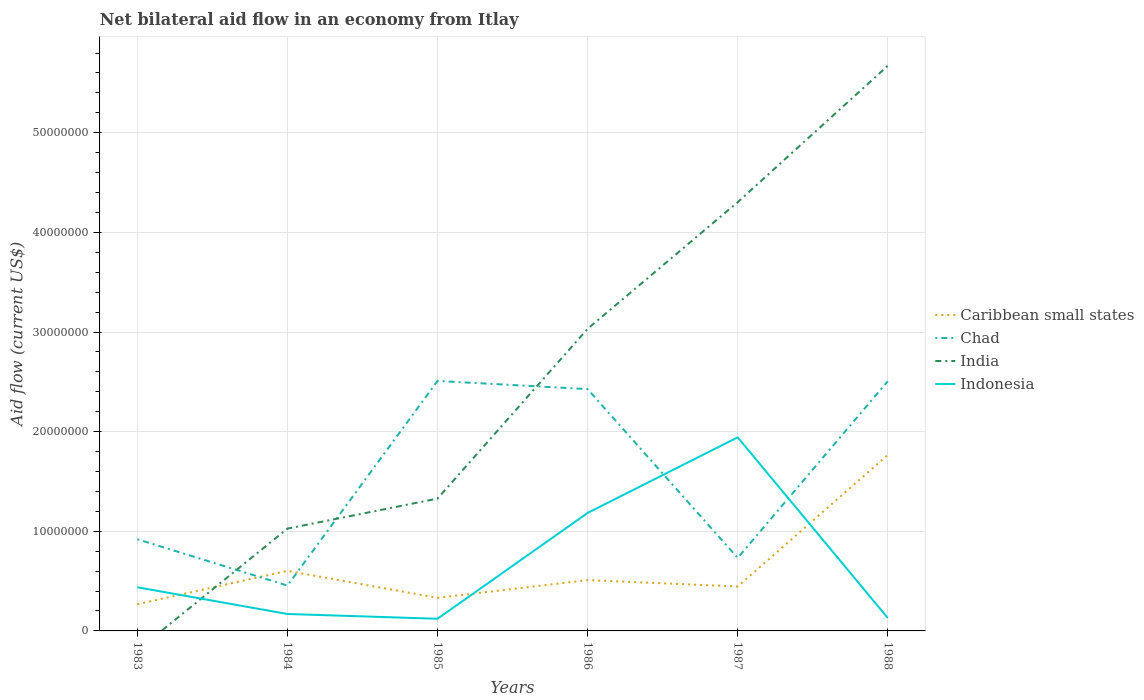Across all years, what is the maximum net bilateral aid flow in India?
Your response must be concise. 0. What is the total net bilateral aid flow in Indonesia in the graph?
Ensure brevity in your answer.  -7.59e+06. What is the difference between the highest and the second highest net bilateral aid flow in Caribbean small states?
Your answer should be compact. 1.50e+07. Is the net bilateral aid flow in Indonesia strictly greater than the net bilateral aid flow in India over the years?
Offer a very short reply. No. Are the values on the major ticks of Y-axis written in scientific E-notation?
Give a very brief answer. No. Does the graph contain any zero values?
Your response must be concise. Yes. Does the graph contain grids?
Your answer should be compact. Yes. Where does the legend appear in the graph?
Your answer should be compact. Center right. What is the title of the graph?
Ensure brevity in your answer.  Net bilateral aid flow in an economy from Itlay. Does "Cameroon" appear as one of the legend labels in the graph?
Provide a short and direct response. No. What is the label or title of the Y-axis?
Provide a succinct answer. Aid flow (current US$). What is the Aid flow (current US$) in Caribbean small states in 1983?
Provide a short and direct response. 2.68e+06. What is the Aid flow (current US$) of Chad in 1983?
Provide a succinct answer. 9.20e+06. What is the Aid flow (current US$) of Indonesia in 1983?
Provide a succinct answer. 4.38e+06. What is the Aid flow (current US$) of Caribbean small states in 1984?
Ensure brevity in your answer.  6.03e+06. What is the Aid flow (current US$) of Chad in 1984?
Offer a terse response. 4.55e+06. What is the Aid flow (current US$) in India in 1984?
Make the answer very short. 1.03e+07. What is the Aid flow (current US$) of Indonesia in 1984?
Your response must be concise. 1.70e+06. What is the Aid flow (current US$) in Caribbean small states in 1985?
Make the answer very short. 3.32e+06. What is the Aid flow (current US$) in Chad in 1985?
Provide a short and direct response. 2.51e+07. What is the Aid flow (current US$) of India in 1985?
Your answer should be very brief. 1.33e+07. What is the Aid flow (current US$) in Indonesia in 1985?
Your answer should be very brief. 1.22e+06. What is the Aid flow (current US$) of Caribbean small states in 1986?
Offer a terse response. 5.10e+06. What is the Aid flow (current US$) in Chad in 1986?
Ensure brevity in your answer.  2.43e+07. What is the Aid flow (current US$) in India in 1986?
Give a very brief answer. 3.03e+07. What is the Aid flow (current US$) in Indonesia in 1986?
Make the answer very short. 1.18e+07. What is the Aid flow (current US$) in Caribbean small states in 1987?
Offer a terse response. 4.46e+06. What is the Aid flow (current US$) of Chad in 1987?
Provide a succinct answer. 7.33e+06. What is the Aid flow (current US$) of India in 1987?
Your answer should be very brief. 4.30e+07. What is the Aid flow (current US$) in Indonesia in 1987?
Offer a very short reply. 1.94e+07. What is the Aid flow (current US$) in Caribbean small states in 1988?
Keep it short and to the point. 1.77e+07. What is the Aid flow (current US$) in Chad in 1988?
Offer a very short reply. 2.51e+07. What is the Aid flow (current US$) of India in 1988?
Ensure brevity in your answer.  5.67e+07. What is the Aid flow (current US$) in Indonesia in 1988?
Provide a succinct answer. 1.30e+06. Across all years, what is the maximum Aid flow (current US$) of Caribbean small states?
Provide a succinct answer. 1.77e+07. Across all years, what is the maximum Aid flow (current US$) of Chad?
Keep it short and to the point. 2.51e+07. Across all years, what is the maximum Aid flow (current US$) of India?
Provide a short and direct response. 5.67e+07. Across all years, what is the maximum Aid flow (current US$) of Indonesia?
Provide a short and direct response. 1.94e+07. Across all years, what is the minimum Aid flow (current US$) in Caribbean small states?
Keep it short and to the point. 2.68e+06. Across all years, what is the minimum Aid flow (current US$) of Chad?
Offer a terse response. 4.55e+06. Across all years, what is the minimum Aid flow (current US$) of India?
Ensure brevity in your answer.  0. Across all years, what is the minimum Aid flow (current US$) in Indonesia?
Ensure brevity in your answer.  1.22e+06. What is the total Aid flow (current US$) in Caribbean small states in the graph?
Provide a short and direct response. 3.92e+07. What is the total Aid flow (current US$) of Chad in the graph?
Give a very brief answer. 9.55e+07. What is the total Aid flow (current US$) in India in the graph?
Your response must be concise. 1.54e+08. What is the total Aid flow (current US$) in Indonesia in the graph?
Give a very brief answer. 3.99e+07. What is the difference between the Aid flow (current US$) in Caribbean small states in 1983 and that in 1984?
Give a very brief answer. -3.35e+06. What is the difference between the Aid flow (current US$) of Chad in 1983 and that in 1984?
Your answer should be compact. 4.65e+06. What is the difference between the Aid flow (current US$) in Indonesia in 1983 and that in 1984?
Provide a succinct answer. 2.68e+06. What is the difference between the Aid flow (current US$) of Caribbean small states in 1983 and that in 1985?
Your response must be concise. -6.40e+05. What is the difference between the Aid flow (current US$) in Chad in 1983 and that in 1985?
Make the answer very short. -1.59e+07. What is the difference between the Aid flow (current US$) of Indonesia in 1983 and that in 1985?
Provide a short and direct response. 3.16e+06. What is the difference between the Aid flow (current US$) of Caribbean small states in 1983 and that in 1986?
Provide a short and direct response. -2.42e+06. What is the difference between the Aid flow (current US$) in Chad in 1983 and that in 1986?
Provide a succinct answer. -1.51e+07. What is the difference between the Aid flow (current US$) in Indonesia in 1983 and that in 1986?
Your answer should be very brief. -7.46e+06. What is the difference between the Aid flow (current US$) in Caribbean small states in 1983 and that in 1987?
Your answer should be very brief. -1.78e+06. What is the difference between the Aid flow (current US$) in Chad in 1983 and that in 1987?
Your response must be concise. 1.87e+06. What is the difference between the Aid flow (current US$) in Indonesia in 1983 and that in 1987?
Give a very brief answer. -1.50e+07. What is the difference between the Aid flow (current US$) in Caribbean small states in 1983 and that in 1988?
Keep it short and to the point. -1.50e+07. What is the difference between the Aid flow (current US$) in Chad in 1983 and that in 1988?
Keep it short and to the point. -1.59e+07. What is the difference between the Aid flow (current US$) of Indonesia in 1983 and that in 1988?
Your answer should be very brief. 3.08e+06. What is the difference between the Aid flow (current US$) of Caribbean small states in 1984 and that in 1985?
Ensure brevity in your answer.  2.71e+06. What is the difference between the Aid flow (current US$) of Chad in 1984 and that in 1985?
Offer a terse response. -2.05e+07. What is the difference between the Aid flow (current US$) in India in 1984 and that in 1985?
Provide a succinct answer. -3.01e+06. What is the difference between the Aid flow (current US$) in Caribbean small states in 1984 and that in 1986?
Your answer should be compact. 9.30e+05. What is the difference between the Aid flow (current US$) in Chad in 1984 and that in 1986?
Your response must be concise. -1.97e+07. What is the difference between the Aid flow (current US$) of India in 1984 and that in 1986?
Provide a succinct answer. -2.00e+07. What is the difference between the Aid flow (current US$) of Indonesia in 1984 and that in 1986?
Your response must be concise. -1.01e+07. What is the difference between the Aid flow (current US$) of Caribbean small states in 1984 and that in 1987?
Give a very brief answer. 1.57e+06. What is the difference between the Aid flow (current US$) in Chad in 1984 and that in 1987?
Your response must be concise. -2.78e+06. What is the difference between the Aid flow (current US$) of India in 1984 and that in 1987?
Give a very brief answer. -3.28e+07. What is the difference between the Aid flow (current US$) of Indonesia in 1984 and that in 1987?
Your answer should be very brief. -1.77e+07. What is the difference between the Aid flow (current US$) of Caribbean small states in 1984 and that in 1988?
Provide a succinct answer. -1.16e+07. What is the difference between the Aid flow (current US$) in Chad in 1984 and that in 1988?
Offer a terse response. -2.05e+07. What is the difference between the Aid flow (current US$) in India in 1984 and that in 1988?
Your answer should be very brief. -4.64e+07. What is the difference between the Aid flow (current US$) in Indonesia in 1984 and that in 1988?
Your response must be concise. 4.00e+05. What is the difference between the Aid flow (current US$) of Caribbean small states in 1985 and that in 1986?
Provide a short and direct response. -1.78e+06. What is the difference between the Aid flow (current US$) in Chad in 1985 and that in 1986?
Provide a short and direct response. 8.20e+05. What is the difference between the Aid flow (current US$) in India in 1985 and that in 1986?
Your response must be concise. -1.70e+07. What is the difference between the Aid flow (current US$) of Indonesia in 1985 and that in 1986?
Your answer should be very brief. -1.06e+07. What is the difference between the Aid flow (current US$) in Caribbean small states in 1985 and that in 1987?
Offer a terse response. -1.14e+06. What is the difference between the Aid flow (current US$) of Chad in 1985 and that in 1987?
Offer a terse response. 1.78e+07. What is the difference between the Aid flow (current US$) of India in 1985 and that in 1987?
Keep it short and to the point. -2.98e+07. What is the difference between the Aid flow (current US$) of Indonesia in 1985 and that in 1987?
Ensure brevity in your answer.  -1.82e+07. What is the difference between the Aid flow (current US$) in Caribbean small states in 1985 and that in 1988?
Your answer should be compact. -1.43e+07. What is the difference between the Aid flow (current US$) in India in 1985 and that in 1988?
Your response must be concise. -4.34e+07. What is the difference between the Aid flow (current US$) in Caribbean small states in 1986 and that in 1987?
Ensure brevity in your answer.  6.40e+05. What is the difference between the Aid flow (current US$) in Chad in 1986 and that in 1987?
Your answer should be compact. 1.69e+07. What is the difference between the Aid flow (current US$) in India in 1986 and that in 1987?
Provide a succinct answer. -1.27e+07. What is the difference between the Aid flow (current US$) of Indonesia in 1986 and that in 1987?
Offer a very short reply. -7.59e+06. What is the difference between the Aid flow (current US$) in Caribbean small states in 1986 and that in 1988?
Give a very brief answer. -1.26e+07. What is the difference between the Aid flow (current US$) in Chad in 1986 and that in 1988?
Make the answer very short. -7.90e+05. What is the difference between the Aid flow (current US$) in India in 1986 and that in 1988?
Provide a short and direct response. -2.64e+07. What is the difference between the Aid flow (current US$) in Indonesia in 1986 and that in 1988?
Offer a terse response. 1.05e+07. What is the difference between the Aid flow (current US$) of Caribbean small states in 1987 and that in 1988?
Offer a very short reply. -1.32e+07. What is the difference between the Aid flow (current US$) in Chad in 1987 and that in 1988?
Offer a very short reply. -1.77e+07. What is the difference between the Aid flow (current US$) in India in 1987 and that in 1988?
Make the answer very short. -1.37e+07. What is the difference between the Aid flow (current US$) of Indonesia in 1987 and that in 1988?
Offer a terse response. 1.81e+07. What is the difference between the Aid flow (current US$) in Caribbean small states in 1983 and the Aid flow (current US$) in Chad in 1984?
Offer a very short reply. -1.87e+06. What is the difference between the Aid flow (current US$) of Caribbean small states in 1983 and the Aid flow (current US$) of India in 1984?
Give a very brief answer. -7.59e+06. What is the difference between the Aid flow (current US$) in Caribbean small states in 1983 and the Aid flow (current US$) in Indonesia in 1984?
Give a very brief answer. 9.80e+05. What is the difference between the Aid flow (current US$) of Chad in 1983 and the Aid flow (current US$) of India in 1984?
Make the answer very short. -1.07e+06. What is the difference between the Aid flow (current US$) of Chad in 1983 and the Aid flow (current US$) of Indonesia in 1984?
Your response must be concise. 7.50e+06. What is the difference between the Aid flow (current US$) of Caribbean small states in 1983 and the Aid flow (current US$) of Chad in 1985?
Offer a terse response. -2.24e+07. What is the difference between the Aid flow (current US$) of Caribbean small states in 1983 and the Aid flow (current US$) of India in 1985?
Offer a very short reply. -1.06e+07. What is the difference between the Aid flow (current US$) of Caribbean small states in 1983 and the Aid flow (current US$) of Indonesia in 1985?
Provide a succinct answer. 1.46e+06. What is the difference between the Aid flow (current US$) in Chad in 1983 and the Aid flow (current US$) in India in 1985?
Your response must be concise. -4.08e+06. What is the difference between the Aid flow (current US$) of Chad in 1983 and the Aid flow (current US$) of Indonesia in 1985?
Your response must be concise. 7.98e+06. What is the difference between the Aid flow (current US$) of Caribbean small states in 1983 and the Aid flow (current US$) of Chad in 1986?
Make the answer very short. -2.16e+07. What is the difference between the Aid flow (current US$) in Caribbean small states in 1983 and the Aid flow (current US$) in India in 1986?
Ensure brevity in your answer.  -2.76e+07. What is the difference between the Aid flow (current US$) in Caribbean small states in 1983 and the Aid flow (current US$) in Indonesia in 1986?
Your answer should be very brief. -9.16e+06. What is the difference between the Aid flow (current US$) in Chad in 1983 and the Aid flow (current US$) in India in 1986?
Provide a short and direct response. -2.11e+07. What is the difference between the Aid flow (current US$) of Chad in 1983 and the Aid flow (current US$) of Indonesia in 1986?
Give a very brief answer. -2.64e+06. What is the difference between the Aid flow (current US$) in Caribbean small states in 1983 and the Aid flow (current US$) in Chad in 1987?
Make the answer very short. -4.65e+06. What is the difference between the Aid flow (current US$) of Caribbean small states in 1983 and the Aid flow (current US$) of India in 1987?
Ensure brevity in your answer.  -4.04e+07. What is the difference between the Aid flow (current US$) of Caribbean small states in 1983 and the Aid flow (current US$) of Indonesia in 1987?
Offer a very short reply. -1.68e+07. What is the difference between the Aid flow (current US$) of Chad in 1983 and the Aid flow (current US$) of India in 1987?
Your answer should be very brief. -3.38e+07. What is the difference between the Aid flow (current US$) in Chad in 1983 and the Aid flow (current US$) in Indonesia in 1987?
Keep it short and to the point. -1.02e+07. What is the difference between the Aid flow (current US$) in Caribbean small states in 1983 and the Aid flow (current US$) in Chad in 1988?
Give a very brief answer. -2.24e+07. What is the difference between the Aid flow (current US$) in Caribbean small states in 1983 and the Aid flow (current US$) in India in 1988?
Your answer should be very brief. -5.40e+07. What is the difference between the Aid flow (current US$) in Caribbean small states in 1983 and the Aid flow (current US$) in Indonesia in 1988?
Offer a terse response. 1.38e+06. What is the difference between the Aid flow (current US$) in Chad in 1983 and the Aid flow (current US$) in India in 1988?
Give a very brief answer. -4.75e+07. What is the difference between the Aid flow (current US$) of Chad in 1983 and the Aid flow (current US$) of Indonesia in 1988?
Offer a terse response. 7.90e+06. What is the difference between the Aid flow (current US$) of Caribbean small states in 1984 and the Aid flow (current US$) of Chad in 1985?
Give a very brief answer. -1.91e+07. What is the difference between the Aid flow (current US$) of Caribbean small states in 1984 and the Aid flow (current US$) of India in 1985?
Provide a short and direct response. -7.25e+06. What is the difference between the Aid flow (current US$) of Caribbean small states in 1984 and the Aid flow (current US$) of Indonesia in 1985?
Provide a short and direct response. 4.81e+06. What is the difference between the Aid flow (current US$) of Chad in 1984 and the Aid flow (current US$) of India in 1985?
Offer a very short reply. -8.73e+06. What is the difference between the Aid flow (current US$) of Chad in 1984 and the Aid flow (current US$) of Indonesia in 1985?
Your response must be concise. 3.33e+06. What is the difference between the Aid flow (current US$) of India in 1984 and the Aid flow (current US$) of Indonesia in 1985?
Offer a terse response. 9.05e+06. What is the difference between the Aid flow (current US$) in Caribbean small states in 1984 and the Aid flow (current US$) in Chad in 1986?
Keep it short and to the point. -1.82e+07. What is the difference between the Aid flow (current US$) in Caribbean small states in 1984 and the Aid flow (current US$) in India in 1986?
Your response must be concise. -2.43e+07. What is the difference between the Aid flow (current US$) of Caribbean small states in 1984 and the Aid flow (current US$) of Indonesia in 1986?
Your answer should be compact. -5.81e+06. What is the difference between the Aid flow (current US$) of Chad in 1984 and the Aid flow (current US$) of India in 1986?
Provide a short and direct response. -2.58e+07. What is the difference between the Aid flow (current US$) of Chad in 1984 and the Aid flow (current US$) of Indonesia in 1986?
Ensure brevity in your answer.  -7.29e+06. What is the difference between the Aid flow (current US$) in India in 1984 and the Aid flow (current US$) in Indonesia in 1986?
Ensure brevity in your answer.  -1.57e+06. What is the difference between the Aid flow (current US$) in Caribbean small states in 1984 and the Aid flow (current US$) in Chad in 1987?
Keep it short and to the point. -1.30e+06. What is the difference between the Aid flow (current US$) in Caribbean small states in 1984 and the Aid flow (current US$) in India in 1987?
Make the answer very short. -3.70e+07. What is the difference between the Aid flow (current US$) in Caribbean small states in 1984 and the Aid flow (current US$) in Indonesia in 1987?
Your answer should be very brief. -1.34e+07. What is the difference between the Aid flow (current US$) in Chad in 1984 and the Aid flow (current US$) in India in 1987?
Your answer should be very brief. -3.85e+07. What is the difference between the Aid flow (current US$) of Chad in 1984 and the Aid flow (current US$) of Indonesia in 1987?
Give a very brief answer. -1.49e+07. What is the difference between the Aid flow (current US$) in India in 1984 and the Aid flow (current US$) in Indonesia in 1987?
Give a very brief answer. -9.16e+06. What is the difference between the Aid flow (current US$) of Caribbean small states in 1984 and the Aid flow (current US$) of Chad in 1988?
Your answer should be compact. -1.90e+07. What is the difference between the Aid flow (current US$) of Caribbean small states in 1984 and the Aid flow (current US$) of India in 1988?
Give a very brief answer. -5.07e+07. What is the difference between the Aid flow (current US$) in Caribbean small states in 1984 and the Aid flow (current US$) in Indonesia in 1988?
Offer a terse response. 4.73e+06. What is the difference between the Aid flow (current US$) in Chad in 1984 and the Aid flow (current US$) in India in 1988?
Make the answer very short. -5.22e+07. What is the difference between the Aid flow (current US$) in Chad in 1984 and the Aid flow (current US$) in Indonesia in 1988?
Ensure brevity in your answer.  3.25e+06. What is the difference between the Aid flow (current US$) of India in 1984 and the Aid flow (current US$) of Indonesia in 1988?
Offer a terse response. 8.97e+06. What is the difference between the Aid flow (current US$) in Caribbean small states in 1985 and the Aid flow (current US$) in Chad in 1986?
Provide a succinct answer. -2.10e+07. What is the difference between the Aid flow (current US$) of Caribbean small states in 1985 and the Aid flow (current US$) of India in 1986?
Provide a succinct answer. -2.70e+07. What is the difference between the Aid flow (current US$) of Caribbean small states in 1985 and the Aid flow (current US$) of Indonesia in 1986?
Offer a very short reply. -8.52e+06. What is the difference between the Aid flow (current US$) of Chad in 1985 and the Aid flow (current US$) of India in 1986?
Provide a short and direct response. -5.23e+06. What is the difference between the Aid flow (current US$) of Chad in 1985 and the Aid flow (current US$) of Indonesia in 1986?
Provide a short and direct response. 1.32e+07. What is the difference between the Aid flow (current US$) in India in 1985 and the Aid flow (current US$) in Indonesia in 1986?
Give a very brief answer. 1.44e+06. What is the difference between the Aid flow (current US$) of Caribbean small states in 1985 and the Aid flow (current US$) of Chad in 1987?
Give a very brief answer. -4.01e+06. What is the difference between the Aid flow (current US$) of Caribbean small states in 1985 and the Aid flow (current US$) of India in 1987?
Provide a succinct answer. -3.97e+07. What is the difference between the Aid flow (current US$) in Caribbean small states in 1985 and the Aid flow (current US$) in Indonesia in 1987?
Give a very brief answer. -1.61e+07. What is the difference between the Aid flow (current US$) of Chad in 1985 and the Aid flow (current US$) of India in 1987?
Your answer should be compact. -1.79e+07. What is the difference between the Aid flow (current US$) of Chad in 1985 and the Aid flow (current US$) of Indonesia in 1987?
Make the answer very short. 5.66e+06. What is the difference between the Aid flow (current US$) in India in 1985 and the Aid flow (current US$) in Indonesia in 1987?
Your answer should be very brief. -6.15e+06. What is the difference between the Aid flow (current US$) in Caribbean small states in 1985 and the Aid flow (current US$) in Chad in 1988?
Make the answer very short. -2.17e+07. What is the difference between the Aid flow (current US$) in Caribbean small states in 1985 and the Aid flow (current US$) in India in 1988?
Make the answer very short. -5.34e+07. What is the difference between the Aid flow (current US$) in Caribbean small states in 1985 and the Aid flow (current US$) in Indonesia in 1988?
Keep it short and to the point. 2.02e+06. What is the difference between the Aid flow (current US$) in Chad in 1985 and the Aid flow (current US$) in India in 1988?
Your answer should be very brief. -3.16e+07. What is the difference between the Aid flow (current US$) of Chad in 1985 and the Aid flow (current US$) of Indonesia in 1988?
Keep it short and to the point. 2.38e+07. What is the difference between the Aid flow (current US$) in India in 1985 and the Aid flow (current US$) in Indonesia in 1988?
Keep it short and to the point. 1.20e+07. What is the difference between the Aid flow (current US$) of Caribbean small states in 1986 and the Aid flow (current US$) of Chad in 1987?
Give a very brief answer. -2.23e+06. What is the difference between the Aid flow (current US$) in Caribbean small states in 1986 and the Aid flow (current US$) in India in 1987?
Offer a very short reply. -3.79e+07. What is the difference between the Aid flow (current US$) of Caribbean small states in 1986 and the Aid flow (current US$) of Indonesia in 1987?
Keep it short and to the point. -1.43e+07. What is the difference between the Aid flow (current US$) of Chad in 1986 and the Aid flow (current US$) of India in 1987?
Make the answer very short. -1.88e+07. What is the difference between the Aid flow (current US$) in Chad in 1986 and the Aid flow (current US$) in Indonesia in 1987?
Keep it short and to the point. 4.84e+06. What is the difference between the Aid flow (current US$) in India in 1986 and the Aid flow (current US$) in Indonesia in 1987?
Ensure brevity in your answer.  1.09e+07. What is the difference between the Aid flow (current US$) of Caribbean small states in 1986 and the Aid flow (current US$) of Chad in 1988?
Provide a short and direct response. -2.00e+07. What is the difference between the Aid flow (current US$) of Caribbean small states in 1986 and the Aid flow (current US$) of India in 1988?
Ensure brevity in your answer.  -5.16e+07. What is the difference between the Aid flow (current US$) in Caribbean small states in 1986 and the Aid flow (current US$) in Indonesia in 1988?
Ensure brevity in your answer.  3.80e+06. What is the difference between the Aid flow (current US$) of Chad in 1986 and the Aid flow (current US$) of India in 1988?
Give a very brief answer. -3.24e+07. What is the difference between the Aid flow (current US$) of Chad in 1986 and the Aid flow (current US$) of Indonesia in 1988?
Your answer should be very brief. 2.30e+07. What is the difference between the Aid flow (current US$) of India in 1986 and the Aid flow (current US$) of Indonesia in 1988?
Provide a succinct answer. 2.90e+07. What is the difference between the Aid flow (current US$) in Caribbean small states in 1987 and the Aid flow (current US$) in Chad in 1988?
Give a very brief answer. -2.06e+07. What is the difference between the Aid flow (current US$) in Caribbean small states in 1987 and the Aid flow (current US$) in India in 1988?
Your answer should be very brief. -5.23e+07. What is the difference between the Aid flow (current US$) in Caribbean small states in 1987 and the Aid flow (current US$) in Indonesia in 1988?
Give a very brief answer. 3.16e+06. What is the difference between the Aid flow (current US$) in Chad in 1987 and the Aid flow (current US$) in India in 1988?
Make the answer very short. -4.94e+07. What is the difference between the Aid flow (current US$) of Chad in 1987 and the Aid flow (current US$) of Indonesia in 1988?
Provide a short and direct response. 6.03e+06. What is the difference between the Aid flow (current US$) of India in 1987 and the Aid flow (current US$) of Indonesia in 1988?
Provide a short and direct response. 4.17e+07. What is the average Aid flow (current US$) in Caribbean small states per year?
Your response must be concise. 6.54e+06. What is the average Aid flow (current US$) in Chad per year?
Make the answer very short. 1.59e+07. What is the average Aid flow (current US$) in India per year?
Your answer should be compact. 2.56e+07. What is the average Aid flow (current US$) of Indonesia per year?
Ensure brevity in your answer.  6.64e+06. In the year 1983, what is the difference between the Aid flow (current US$) of Caribbean small states and Aid flow (current US$) of Chad?
Give a very brief answer. -6.52e+06. In the year 1983, what is the difference between the Aid flow (current US$) in Caribbean small states and Aid flow (current US$) in Indonesia?
Provide a short and direct response. -1.70e+06. In the year 1983, what is the difference between the Aid flow (current US$) in Chad and Aid flow (current US$) in Indonesia?
Keep it short and to the point. 4.82e+06. In the year 1984, what is the difference between the Aid flow (current US$) of Caribbean small states and Aid flow (current US$) of Chad?
Provide a succinct answer. 1.48e+06. In the year 1984, what is the difference between the Aid flow (current US$) of Caribbean small states and Aid flow (current US$) of India?
Offer a very short reply. -4.24e+06. In the year 1984, what is the difference between the Aid flow (current US$) of Caribbean small states and Aid flow (current US$) of Indonesia?
Offer a terse response. 4.33e+06. In the year 1984, what is the difference between the Aid flow (current US$) in Chad and Aid flow (current US$) in India?
Give a very brief answer. -5.72e+06. In the year 1984, what is the difference between the Aid flow (current US$) in Chad and Aid flow (current US$) in Indonesia?
Give a very brief answer. 2.85e+06. In the year 1984, what is the difference between the Aid flow (current US$) of India and Aid flow (current US$) of Indonesia?
Your answer should be compact. 8.57e+06. In the year 1985, what is the difference between the Aid flow (current US$) in Caribbean small states and Aid flow (current US$) in Chad?
Give a very brief answer. -2.18e+07. In the year 1985, what is the difference between the Aid flow (current US$) in Caribbean small states and Aid flow (current US$) in India?
Ensure brevity in your answer.  -9.96e+06. In the year 1985, what is the difference between the Aid flow (current US$) in Caribbean small states and Aid flow (current US$) in Indonesia?
Provide a short and direct response. 2.10e+06. In the year 1985, what is the difference between the Aid flow (current US$) in Chad and Aid flow (current US$) in India?
Ensure brevity in your answer.  1.18e+07. In the year 1985, what is the difference between the Aid flow (current US$) in Chad and Aid flow (current US$) in Indonesia?
Keep it short and to the point. 2.39e+07. In the year 1985, what is the difference between the Aid flow (current US$) in India and Aid flow (current US$) in Indonesia?
Make the answer very short. 1.21e+07. In the year 1986, what is the difference between the Aid flow (current US$) of Caribbean small states and Aid flow (current US$) of Chad?
Provide a succinct answer. -1.92e+07. In the year 1986, what is the difference between the Aid flow (current US$) in Caribbean small states and Aid flow (current US$) in India?
Your answer should be very brief. -2.52e+07. In the year 1986, what is the difference between the Aid flow (current US$) of Caribbean small states and Aid flow (current US$) of Indonesia?
Provide a short and direct response. -6.74e+06. In the year 1986, what is the difference between the Aid flow (current US$) in Chad and Aid flow (current US$) in India?
Offer a terse response. -6.05e+06. In the year 1986, what is the difference between the Aid flow (current US$) of Chad and Aid flow (current US$) of Indonesia?
Give a very brief answer. 1.24e+07. In the year 1986, what is the difference between the Aid flow (current US$) in India and Aid flow (current US$) in Indonesia?
Make the answer very short. 1.85e+07. In the year 1987, what is the difference between the Aid flow (current US$) in Caribbean small states and Aid flow (current US$) in Chad?
Your answer should be very brief. -2.87e+06. In the year 1987, what is the difference between the Aid flow (current US$) in Caribbean small states and Aid flow (current US$) in India?
Provide a short and direct response. -3.86e+07. In the year 1987, what is the difference between the Aid flow (current US$) of Caribbean small states and Aid flow (current US$) of Indonesia?
Provide a succinct answer. -1.50e+07. In the year 1987, what is the difference between the Aid flow (current US$) in Chad and Aid flow (current US$) in India?
Your answer should be compact. -3.57e+07. In the year 1987, what is the difference between the Aid flow (current US$) in Chad and Aid flow (current US$) in Indonesia?
Provide a succinct answer. -1.21e+07. In the year 1987, what is the difference between the Aid flow (current US$) of India and Aid flow (current US$) of Indonesia?
Your answer should be very brief. 2.36e+07. In the year 1988, what is the difference between the Aid flow (current US$) in Caribbean small states and Aid flow (current US$) in Chad?
Offer a very short reply. -7.40e+06. In the year 1988, what is the difference between the Aid flow (current US$) of Caribbean small states and Aid flow (current US$) of India?
Offer a terse response. -3.91e+07. In the year 1988, what is the difference between the Aid flow (current US$) in Caribbean small states and Aid flow (current US$) in Indonesia?
Keep it short and to the point. 1.64e+07. In the year 1988, what is the difference between the Aid flow (current US$) of Chad and Aid flow (current US$) of India?
Ensure brevity in your answer.  -3.17e+07. In the year 1988, what is the difference between the Aid flow (current US$) in Chad and Aid flow (current US$) in Indonesia?
Make the answer very short. 2.38e+07. In the year 1988, what is the difference between the Aid flow (current US$) of India and Aid flow (current US$) of Indonesia?
Offer a very short reply. 5.54e+07. What is the ratio of the Aid flow (current US$) of Caribbean small states in 1983 to that in 1984?
Make the answer very short. 0.44. What is the ratio of the Aid flow (current US$) of Chad in 1983 to that in 1984?
Ensure brevity in your answer.  2.02. What is the ratio of the Aid flow (current US$) in Indonesia in 1983 to that in 1984?
Offer a terse response. 2.58. What is the ratio of the Aid flow (current US$) in Caribbean small states in 1983 to that in 1985?
Offer a very short reply. 0.81. What is the ratio of the Aid flow (current US$) of Chad in 1983 to that in 1985?
Offer a terse response. 0.37. What is the ratio of the Aid flow (current US$) of Indonesia in 1983 to that in 1985?
Your answer should be compact. 3.59. What is the ratio of the Aid flow (current US$) of Caribbean small states in 1983 to that in 1986?
Your answer should be very brief. 0.53. What is the ratio of the Aid flow (current US$) of Chad in 1983 to that in 1986?
Your answer should be very brief. 0.38. What is the ratio of the Aid flow (current US$) of Indonesia in 1983 to that in 1986?
Your response must be concise. 0.37. What is the ratio of the Aid flow (current US$) in Caribbean small states in 1983 to that in 1987?
Offer a very short reply. 0.6. What is the ratio of the Aid flow (current US$) in Chad in 1983 to that in 1987?
Keep it short and to the point. 1.26. What is the ratio of the Aid flow (current US$) in Indonesia in 1983 to that in 1987?
Give a very brief answer. 0.23. What is the ratio of the Aid flow (current US$) of Caribbean small states in 1983 to that in 1988?
Provide a succinct answer. 0.15. What is the ratio of the Aid flow (current US$) in Chad in 1983 to that in 1988?
Provide a short and direct response. 0.37. What is the ratio of the Aid flow (current US$) of Indonesia in 1983 to that in 1988?
Offer a very short reply. 3.37. What is the ratio of the Aid flow (current US$) of Caribbean small states in 1984 to that in 1985?
Provide a succinct answer. 1.82. What is the ratio of the Aid flow (current US$) of Chad in 1984 to that in 1985?
Offer a very short reply. 0.18. What is the ratio of the Aid flow (current US$) in India in 1984 to that in 1985?
Your answer should be very brief. 0.77. What is the ratio of the Aid flow (current US$) of Indonesia in 1984 to that in 1985?
Offer a terse response. 1.39. What is the ratio of the Aid flow (current US$) of Caribbean small states in 1984 to that in 1986?
Keep it short and to the point. 1.18. What is the ratio of the Aid flow (current US$) in Chad in 1984 to that in 1986?
Offer a very short reply. 0.19. What is the ratio of the Aid flow (current US$) of India in 1984 to that in 1986?
Your answer should be very brief. 0.34. What is the ratio of the Aid flow (current US$) of Indonesia in 1984 to that in 1986?
Offer a terse response. 0.14. What is the ratio of the Aid flow (current US$) of Caribbean small states in 1984 to that in 1987?
Your answer should be very brief. 1.35. What is the ratio of the Aid flow (current US$) in Chad in 1984 to that in 1987?
Keep it short and to the point. 0.62. What is the ratio of the Aid flow (current US$) of India in 1984 to that in 1987?
Your response must be concise. 0.24. What is the ratio of the Aid flow (current US$) in Indonesia in 1984 to that in 1987?
Offer a terse response. 0.09. What is the ratio of the Aid flow (current US$) in Caribbean small states in 1984 to that in 1988?
Your answer should be compact. 0.34. What is the ratio of the Aid flow (current US$) of Chad in 1984 to that in 1988?
Make the answer very short. 0.18. What is the ratio of the Aid flow (current US$) in India in 1984 to that in 1988?
Make the answer very short. 0.18. What is the ratio of the Aid flow (current US$) of Indonesia in 1984 to that in 1988?
Give a very brief answer. 1.31. What is the ratio of the Aid flow (current US$) of Caribbean small states in 1985 to that in 1986?
Make the answer very short. 0.65. What is the ratio of the Aid flow (current US$) of Chad in 1985 to that in 1986?
Provide a short and direct response. 1.03. What is the ratio of the Aid flow (current US$) in India in 1985 to that in 1986?
Offer a terse response. 0.44. What is the ratio of the Aid flow (current US$) in Indonesia in 1985 to that in 1986?
Give a very brief answer. 0.1. What is the ratio of the Aid flow (current US$) in Caribbean small states in 1985 to that in 1987?
Keep it short and to the point. 0.74. What is the ratio of the Aid flow (current US$) in Chad in 1985 to that in 1987?
Your answer should be very brief. 3.42. What is the ratio of the Aid flow (current US$) of India in 1985 to that in 1987?
Your response must be concise. 0.31. What is the ratio of the Aid flow (current US$) of Indonesia in 1985 to that in 1987?
Offer a terse response. 0.06. What is the ratio of the Aid flow (current US$) of Caribbean small states in 1985 to that in 1988?
Offer a terse response. 0.19. What is the ratio of the Aid flow (current US$) in Chad in 1985 to that in 1988?
Make the answer very short. 1. What is the ratio of the Aid flow (current US$) in India in 1985 to that in 1988?
Keep it short and to the point. 0.23. What is the ratio of the Aid flow (current US$) in Indonesia in 1985 to that in 1988?
Your answer should be compact. 0.94. What is the ratio of the Aid flow (current US$) in Caribbean small states in 1986 to that in 1987?
Provide a succinct answer. 1.14. What is the ratio of the Aid flow (current US$) of Chad in 1986 to that in 1987?
Make the answer very short. 3.31. What is the ratio of the Aid flow (current US$) of India in 1986 to that in 1987?
Offer a very short reply. 0.7. What is the ratio of the Aid flow (current US$) in Indonesia in 1986 to that in 1987?
Provide a succinct answer. 0.61. What is the ratio of the Aid flow (current US$) of Caribbean small states in 1986 to that in 1988?
Give a very brief answer. 0.29. What is the ratio of the Aid flow (current US$) in Chad in 1986 to that in 1988?
Offer a terse response. 0.97. What is the ratio of the Aid flow (current US$) of India in 1986 to that in 1988?
Provide a succinct answer. 0.53. What is the ratio of the Aid flow (current US$) in Indonesia in 1986 to that in 1988?
Provide a short and direct response. 9.11. What is the ratio of the Aid flow (current US$) of Caribbean small states in 1987 to that in 1988?
Offer a terse response. 0.25. What is the ratio of the Aid flow (current US$) of Chad in 1987 to that in 1988?
Your response must be concise. 0.29. What is the ratio of the Aid flow (current US$) of India in 1987 to that in 1988?
Offer a very short reply. 0.76. What is the ratio of the Aid flow (current US$) of Indonesia in 1987 to that in 1988?
Keep it short and to the point. 14.95. What is the difference between the highest and the second highest Aid flow (current US$) of Caribbean small states?
Provide a short and direct response. 1.16e+07. What is the difference between the highest and the second highest Aid flow (current US$) of India?
Give a very brief answer. 1.37e+07. What is the difference between the highest and the second highest Aid flow (current US$) of Indonesia?
Your answer should be very brief. 7.59e+06. What is the difference between the highest and the lowest Aid flow (current US$) in Caribbean small states?
Provide a succinct answer. 1.50e+07. What is the difference between the highest and the lowest Aid flow (current US$) of Chad?
Your answer should be very brief. 2.05e+07. What is the difference between the highest and the lowest Aid flow (current US$) in India?
Make the answer very short. 5.67e+07. What is the difference between the highest and the lowest Aid flow (current US$) in Indonesia?
Your answer should be compact. 1.82e+07. 